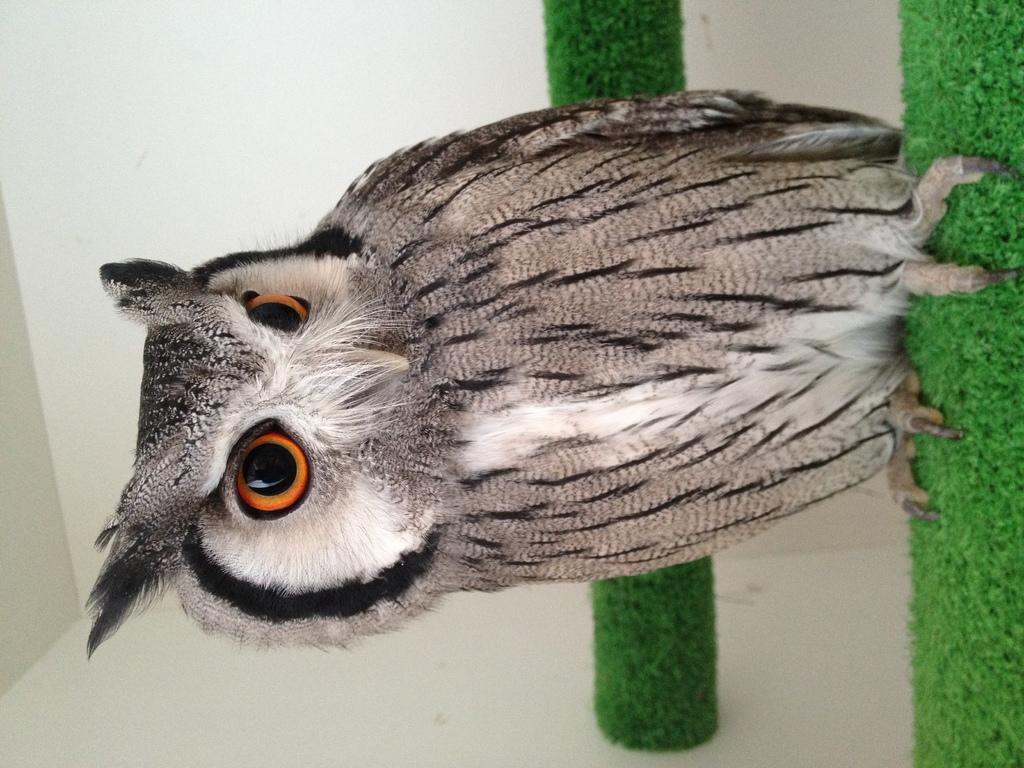Can you describe this image briefly? In this picture we can see an owl on the object and behind the owl there is an artificial grass and a wall. 